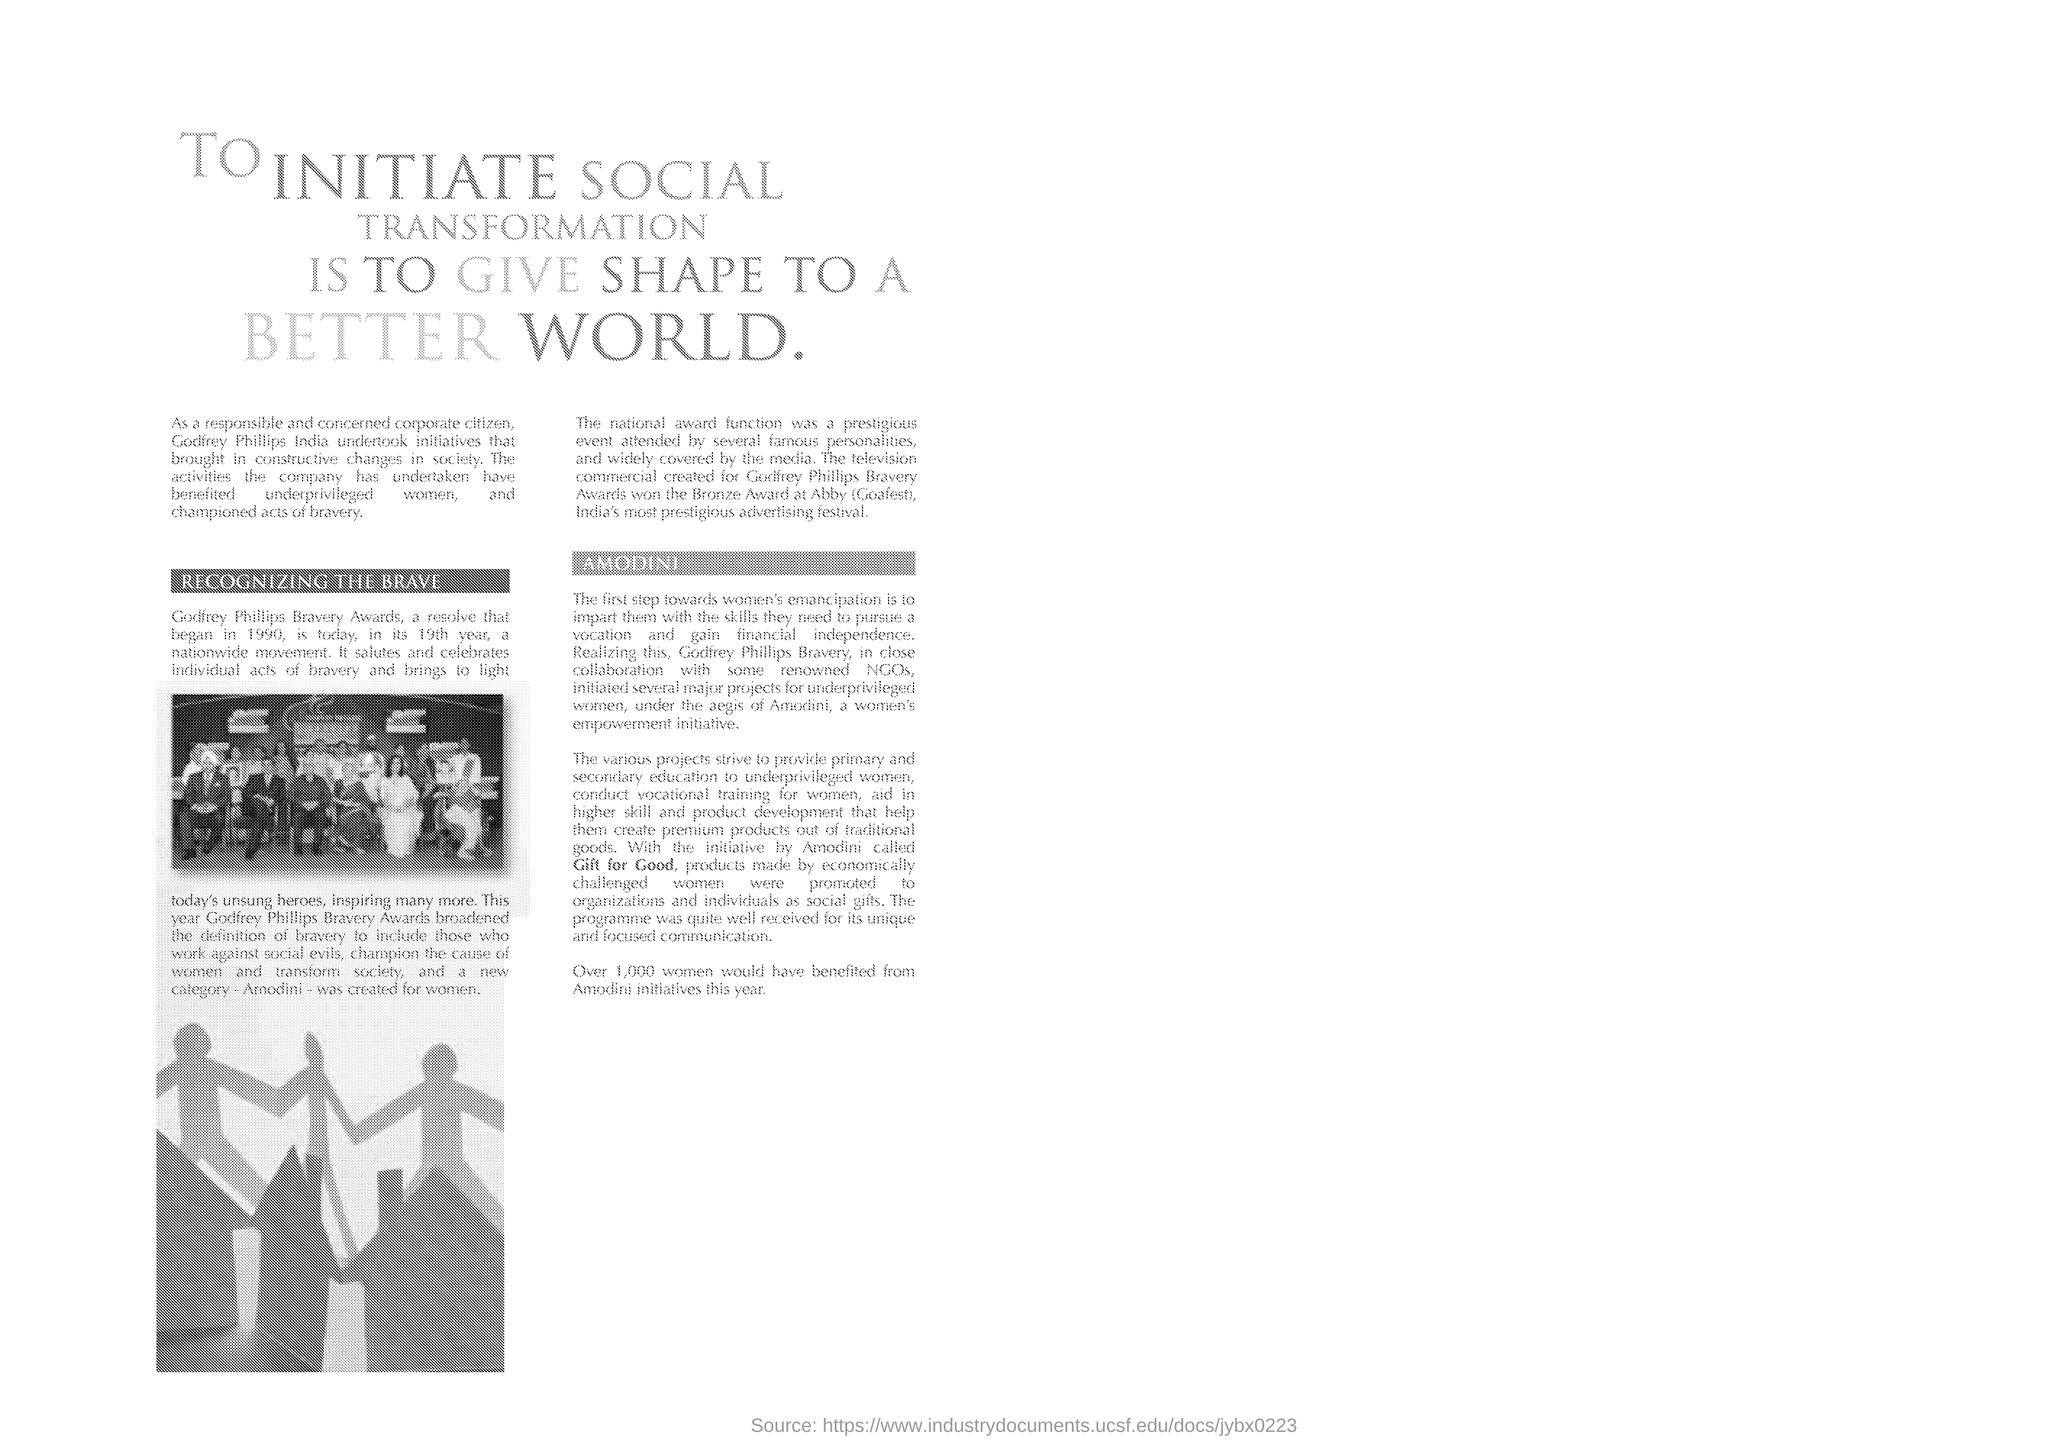What is the heading of the document?
Ensure brevity in your answer.  To initiate social transformation is to give shape to a better world. Who "undertook initiatives that brought in constructive changes in society"?
Make the answer very short. Godfrey phillips India. What is the first subheading given in the document?
Your answer should be compact. RECOGNIZING THE BRAVE. Which is the "resolve that began in 1990"?
Your response must be concise. Godfrey Phillips Bravery Awards. "Godfrey Phillips Bravery Awards" began in which year?
Your response must be concise. 1990. Which new category was created for women in Godfrey Phillips Bravery Awards?
Offer a terse response. Amodini. The television commercial created for Godfrey Phillips Bravery Awards won which award?
Keep it short and to the point. Bronze. Which initiative by Amodini promoted products made by economically challenged women?
Provide a short and direct response. Gift for Good. Over how many women would have benefited from Amodini initiatives this year?
Offer a terse response. 1,000. 